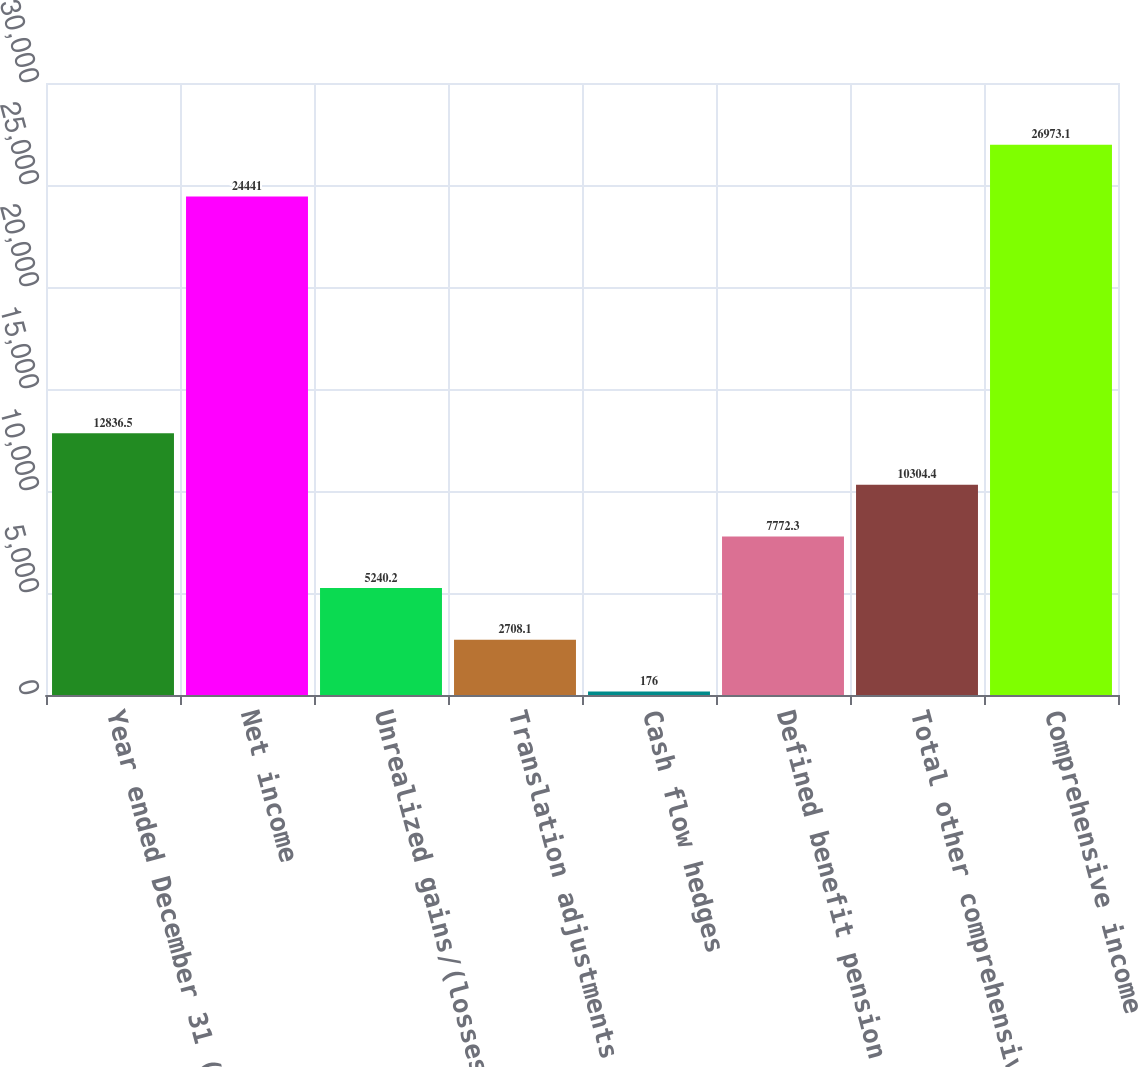<chart> <loc_0><loc_0><loc_500><loc_500><bar_chart><fcel>Year ended December 31 (in<fcel>Net income<fcel>Unrealized gains/(losses) on<fcel>Translation adjustments net of<fcel>Cash flow hedges<fcel>Defined benefit pension and<fcel>Total other comprehensive<fcel>Comprehensive income<nl><fcel>12836.5<fcel>24441<fcel>5240.2<fcel>2708.1<fcel>176<fcel>7772.3<fcel>10304.4<fcel>26973.1<nl></chart> 